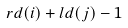Convert formula to latex. <formula><loc_0><loc_0><loc_500><loc_500>r d ( i ) + l d ( j ) - 1</formula> 